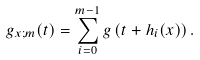<formula> <loc_0><loc_0><loc_500><loc_500>g _ { x ; m } ( t ) = \sum _ { i = 0 } ^ { m - 1 } g \left ( t + h _ { i } ( x ) \right ) .</formula> 